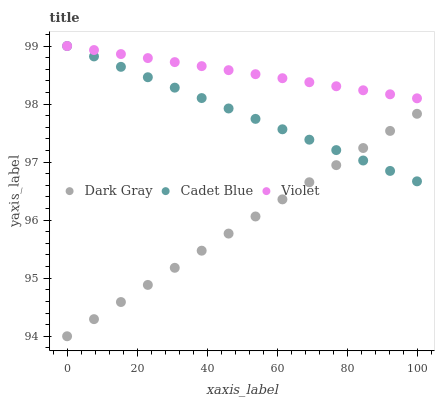Does Dark Gray have the minimum area under the curve?
Answer yes or no. Yes. Does Violet have the maximum area under the curve?
Answer yes or no. Yes. Does Cadet Blue have the minimum area under the curve?
Answer yes or no. No. Does Cadet Blue have the maximum area under the curve?
Answer yes or no. No. Is Cadet Blue the smoothest?
Answer yes or no. Yes. Is Dark Gray the roughest?
Answer yes or no. Yes. Is Violet the smoothest?
Answer yes or no. No. Is Violet the roughest?
Answer yes or no. No. Does Dark Gray have the lowest value?
Answer yes or no. Yes. Does Cadet Blue have the lowest value?
Answer yes or no. No. Does Violet have the highest value?
Answer yes or no. Yes. Is Dark Gray less than Violet?
Answer yes or no. Yes. Is Violet greater than Dark Gray?
Answer yes or no. Yes. Does Dark Gray intersect Cadet Blue?
Answer yes or no. Yes. Is Dark Gray less than Cadet Blue?
Answer yes or no. No. Is Dark Gray greater than Cadet Blue?
Answer yes or no. No. Does Dark Gray intersect Violet?
Answer yes or no. No. 